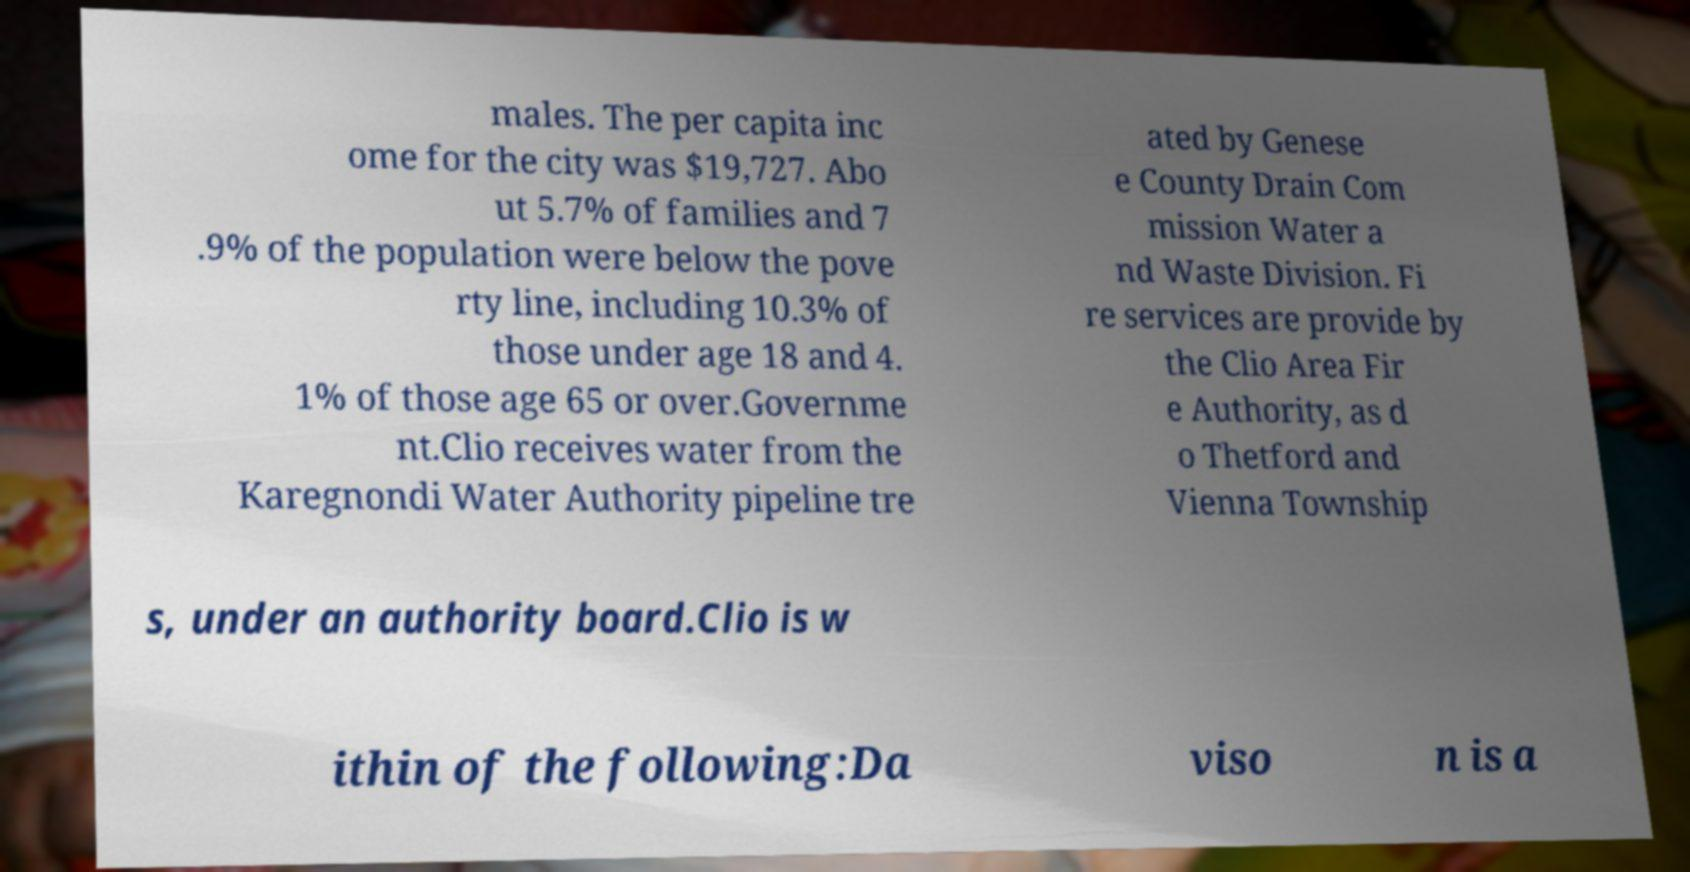For documentation purposes, I need the text within this image transcribed. Could you provide that? males. The per capita inc ome for the city was $19,727. Abo ut 5.7% of families and 7 .9% of the population were below the pove rty line, including 10.3% of those under age 18 and 4. 1% of those age 65 or over.Governme nt.Clio receives water from the Karegnondi Water Authority pipeline tre ated by Genese e County Drain Com mission Water a nd Waste Division. Fi re services are provide by the Clio Area Fir e Authority, as d o Thetford and Vienna Township s, under an authority board.Clio is w ithin of the following:Da viso n is a 